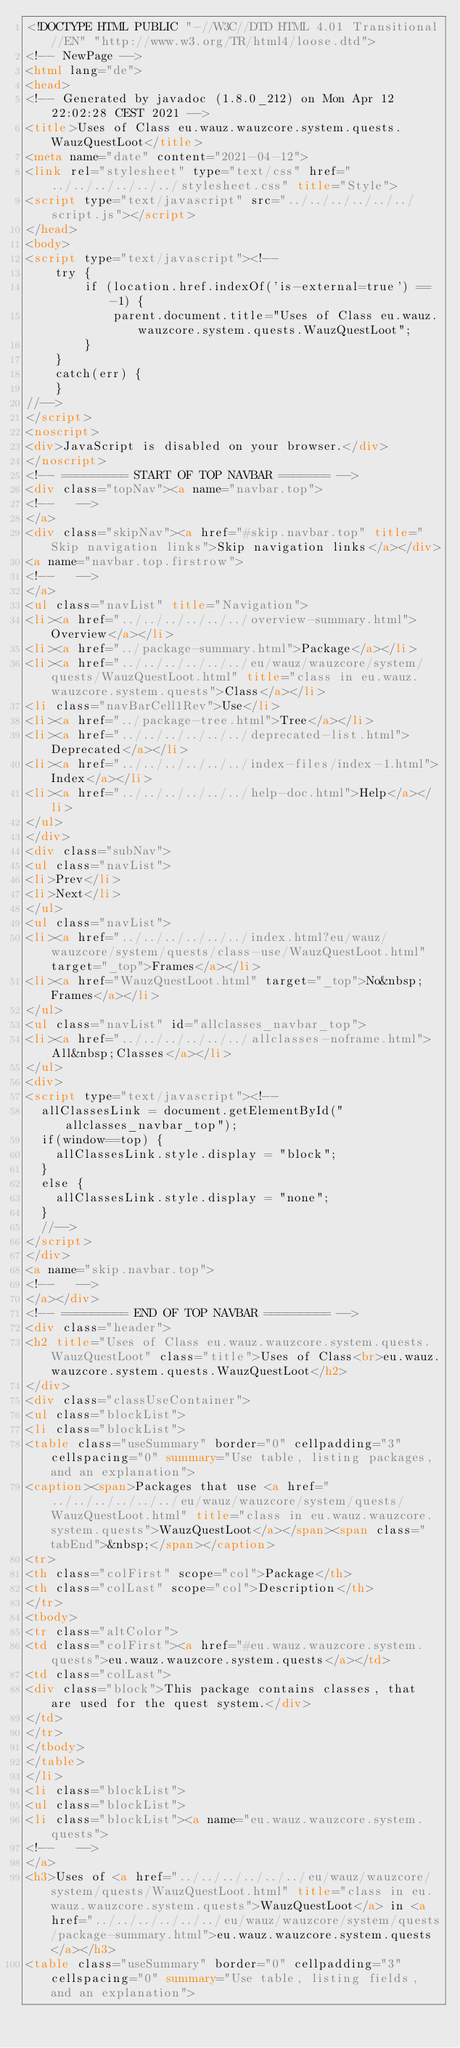<code> <loc_0><loc_0><loc_500><loc_500><_HTML_><!DOCTYPE HTML PUBLIC "-//W3C//DTD HTML 4.01 Transitional//EN" "http://www.w3.org/TR/html4/loose.dtd">
<!-- NewPage -->
<html lang="de">
<head>
<!-- Generated by javadoc (1.8.0_212) on Mon Apr 12 22:02:28 CEST 2021 -->
<title>Uses of Class eu.wauz.wauzcore.system.quests.WauzQuestLoot</title>
<meta name="date" content="2021-04-12">
<link rel="stylesheet" type="text/css" href="../../../../../../stylesheet.css" title="Style">
<script type="text/javascript" src="../../../../../../script.js"></script>
</head>
<body>
<script type="text/javascript"><!--
    try {
        if (location.href.indexOf('is-external=true') == -1) {
            parent.document.title="Uses of Class eu.wauz.wauzcore.system.quests.WauzQuestLoot";
        }
    }
    catch(err) {
    }
//-->
</script>
<noscript>
<div>JavaScript is disabled on your browser.</div>
</noscript>
<!-- ========= START OF TOP NAVBAR ======= -->
<div class="topNav"><a name="navbar.top">
<!--   -->
</a>
<div class="skipNav"><a href="#skip.navbar.top" title="Skip navigation links">Skip navigation links</a></div>
<a name="navbar.top.firstrow">
<!--   -->
</a>
<ul class="navList" title="Navigation">
<li><a href="../../../../../../overview-summary.html">Overview</a></li>
<li><a href="../package-summary.html">Package</a></li>
<li><a href="../../../../../../eu/wauz/wauzcore/system/quests/WauzQuestLoot.html" title="class in eu.wauz.wauzcore.system.quests">Class</a></li>
<li class="navBarCell1Rev">Use</li>
<li><a href="../package-tree.html">Tree</a></li>
<li><a href="../../../../../../deprecated-list.html">Deprecated</a></li>
<li><a href="../../../../../../index-files/index-1.html">Index</a></li>
<li><a href="../../../../../../help-doc.html">Help</a></li>
</ul>
</div>
<div class="subNav">
<ul class="navList">
<li>Prev</li>
<li>Next</li>
</ul>
<ul class="navList">
<li><a href="../../../../../../index.html?eu/wauz/wauzcore/system/quests/class-use/WauzQuestLoot.html" target="_top">Frames</a></li>
<li><a href="WauzQuestLoot.html" target="_top">No&nbsp;Frames</a></li>
</ul>
<ul class="navList" id="allclasses_navbar_top">
<li><a href="../../../../../../allclasses-noframe.html">All&nbsp;Classes</a></li>
</ul>
<div>
<script type="text/javascript"><!--
  allClassesLink = document.getElementById("allclasses_navbar_top");
  if(window==top) {
    allClassesLink.style.display = "block";
  }
  else {
    allClassesLink.style.display = "none";
  }
  //-->
</script>
</div>
<a name="skip.navbar.top">
<!--   -->
</a></div>
<!-- ========= END OF TOP NAVBAR ========= -->
<div class="header">
<h2 title="Uses of Class eu.wauz.wauzcore.system.quests.WauzQuestLoot" class="title">Uses of Class<br>eu.wauz.wauzcore.system.quests.WauzQuestLoot</h2>
</div>
<div class="classUseContainer">
<ul class="blockList">
<li class="blockList">
<table class="useSummary" border="0" cellpadding="3" cellspacing="0" summary="Use table, listing packages, and an explanation">
<caption><span>Packages that use <a href="../../../../../../eu/wauz/wauzcore/system/quests/WauzQuestLoot.html" title="class in eu.wauz.wauzcore.system.quests">WauzQuestLoot</a></span><span class="tabEnd">&nbsp;</span></caption>
<tr>
<th class="colFirst" scope="col">Package</th>
<th class="colLast" scope="col">Description</th>
</tr>
<tbody>
<tr class="altColor">
<td class="colFirst"><a href="#eu.wauz.wauzcore.system.quests">eu.wauz.wauzcore.system.quests</a></td>
<td class="colLast">
<div class="block">This package contains classes, that are used for the quest system.</div>
</td>
</tr>
</tbody>
</table>
</li>
<li class="blockList">
<ul class="blockList">
<li class="blockList"><a name="eu.wauz.wauzcore.system.quests">
<!--   -->
</a>
<h3>Uses of <a href="../../../../../../eu/wauz/wauzcore/system/quests/WauzQuestLoot.html" title="class in eu.wauz.wauzcore.system.quests">WauzQuestLoot</a> in <a href="../../../../../../eu/wauz/wauzcore/system/quests/package-summary.html">eu.wauz.wauzcore.system.quests</a></h3>
<table class="useSummary" border="0" cellpadding="3" cellspacing="0" summary="Use table, listing fields, and an explanation"></code> 